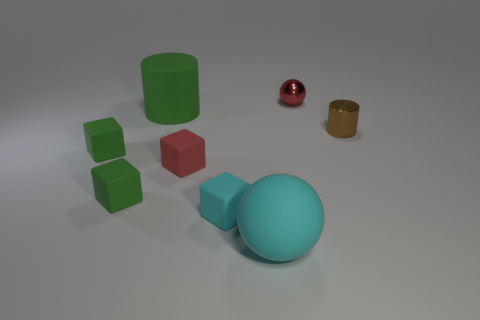What size is the object that is both in front of the small brown metallic cylinder and to the right of the small cyan block?
Provide a succinct answer. Large. What number of red rubber things are the same size as the cyan block?
Provide a succinct answer. 1. There is a large rubber thing behind the tiny brown shiny thing; does it have the same shape as the small brown thing?
Ensure brevity in your answer.  Yes. Is the number of small balls that are on the left side of the red shiny object less than the number of green matte blocks?
Ensure brevity in your answer.  Yes. Are there any blocks that have the same color as the large cylinder?
Ensure brevity in your answer.  Yes. Does the tiny cyan thing have the same shape as the red object that is in front of the green cylinder?
Give a very brief answer. Yes. Is there a brown object made of the same material as the tiny ball?
Your response must be concise. Yes. There is a tiny green rubber cube that is in front of the tiny matte block behind the red block; is there a green rubber block that is to the right of it?
Your response must be concise. No. How many other objects are there of the same shape as the big green rubber object?
Your answer should be compact. 1. There is a small rubber block behind the red object that is left of the small red thing that is right of the tiny cyan rubber object; what is its color?
Provide a succinct answer. Green. 